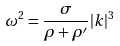Convert formula to latex. <formula><loc_0><loc_0><loc_500><loc_500>\omega ^ { 2 } = \frac { \sigma } { \rho + \rho ^ { \prime } } | k | ^ { 3 }</formula> 